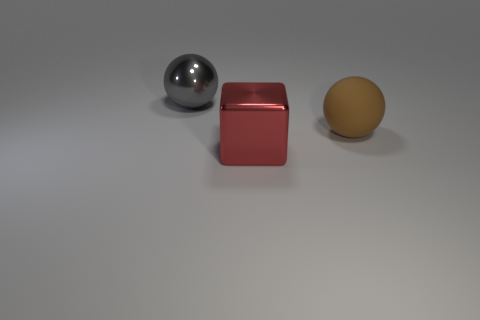Is there anything else that is the same material as the large brown thing?
Your answer should be compact. No. The large thing that is made of the same material as the gray ball is what color?
Your answer should be compact. Red. What shape is the gray thing?
Ensure brevity in your answer.  Sphere. There is a rubber thing that is the same size as the gray ball; what is its shape?
Your answer should be compact. Sphere. Is there another brown ball of the same size as the brown ball?
Offer a terse response. No. There is another ball that is the same size as the brown sphere; what material is it?
Keep it short and to the point. Metal. There is a metal object that is in front of the ball that is in front of the big gray shiny object; how big is it?
Provide a short and direct response. Large. Is the size of the sphere that is on the right side of the red metal cube the same as the large gray shiny thing?
Keep it short and to the point. Yes. Are there more things behind the brown matte thing than gray balls that are in front of the large red metallic cube?
Give a very brief answer. Yes. The big thing that is both behind the cube and to the left of the brown ball has what shape?
Ensure brevity in your answer.  Sphere. 